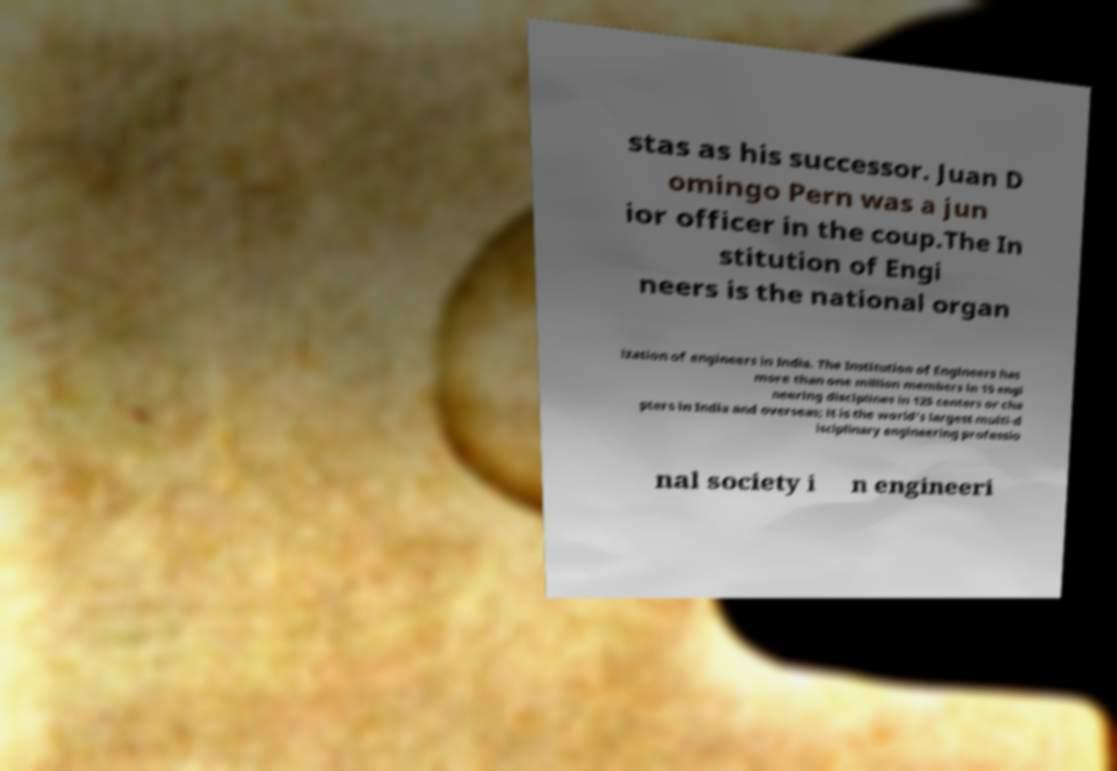There's text embedded in this image that I need extracted. Can you transcribe it verbatim? stas as his successor. Juan D omingo Pern was a jun ior officer in the coup.The In stitution of Engi neers is the national organ ization of engineers in India. The Institution of Engineers has more than one million members in 15 engi neering disciplines in 125 centers or cha pters in India and overseas; it is the world's largest multi-d isciplinary engineering professio nal society i n engineeri 